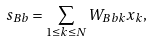<formula> <loc_0><loc_0><loc_500><loc_500>s _ { B b } = \sum _ { 1 \leq k \leq N } W _ { B b k } x _ { k } ,</formula> 